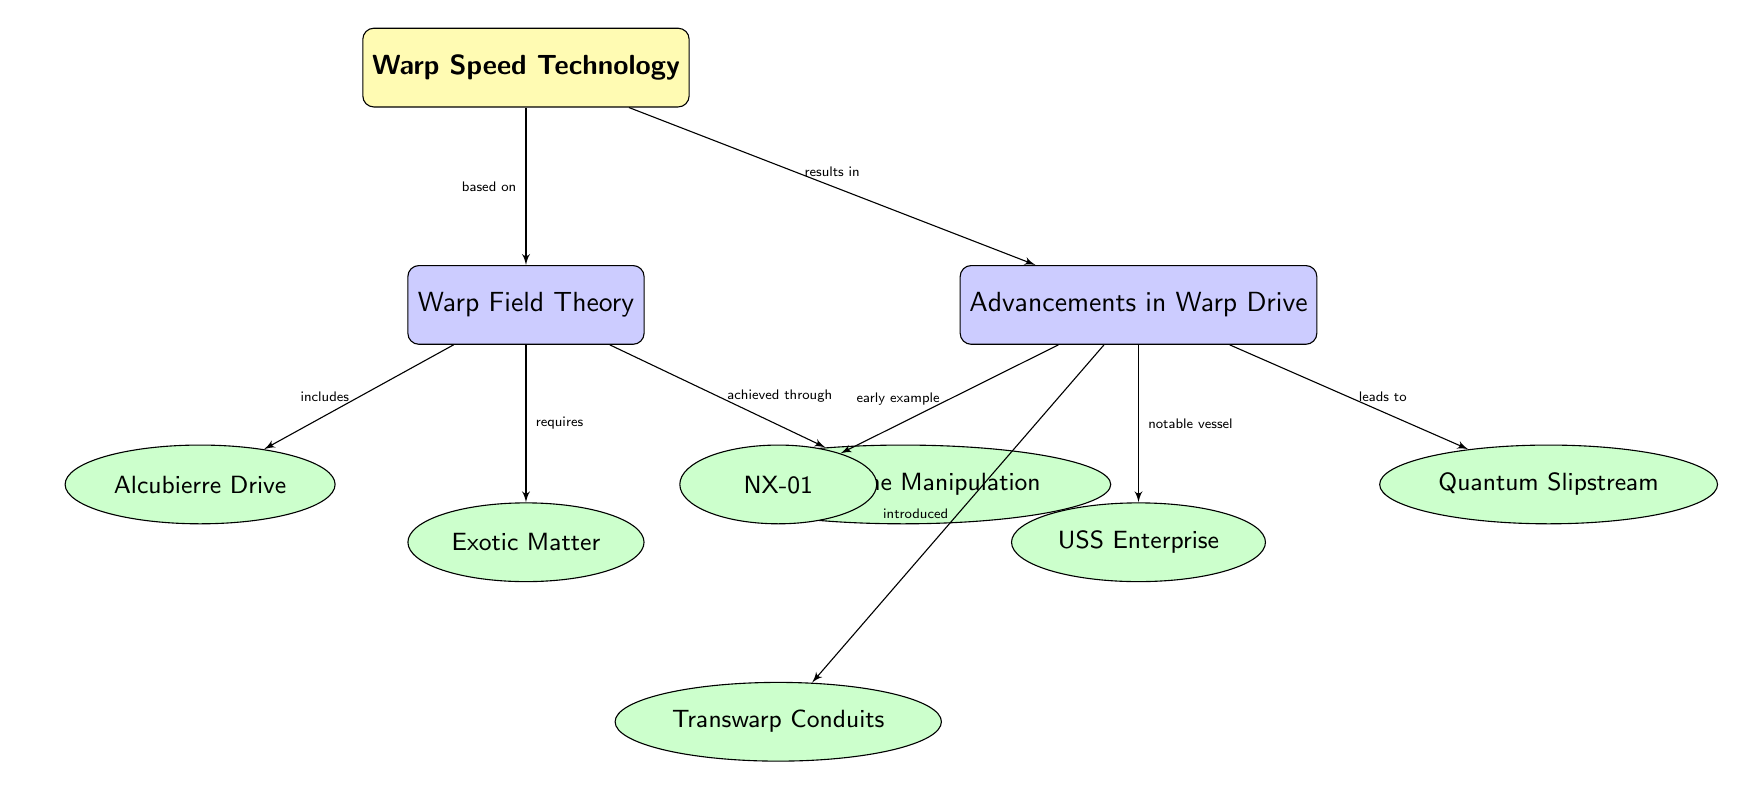What is the title of the diagram? The title is explicitly labeled at the top of the diagram, which is visually distinct and in a yellow filled box.
Answer: Warp Speed Technology How many subcategories are listed under Warp Field Theory? By counting the nodes directly beneath "Warp Field Theory," we see there are three listed: Alcubierre Drive, Exotic Matter, and Space-Time Manipulation.
Answer: 3 What does the Alcubierre Drive relate to in the context of Warp Field Theory? The line from "Warp Field Theory" to "Alcubierre Drive" is labeled as "includes," showing that the Alcubierre Drive is a part of the theory.
Answer: includes What notable vessel is mentioned in relation to advancements in Warp Drive? The node connected to "Advancements in Warp Drive" labeled "USS Enterprise" indicates this is the notable vessel referred to.
Answer: USS Enterprise Which drive introduces Transwarp Conduits? The node "Transwarp Conduits" is directly linked to the node "NX-01" under "Advancements in Warp Drive," indicating that NX-01 is the drive that introduced Transwarp Conduits.
Answer: NX-01 What is required for Warp Field Theory according to the diagram? The node below "Warp Field Theory" and connected with an arrow labeled "requires" identifies "Exotic Matter" as a requirement.
Answer: Exotic Matter What type of technology is Quantum Slipstream classified under? The arrow labeled "leads to" connects "Advancements in Warp Drive" to "Quantum Slipstream," indicating that Quantum Slipstream is an advancement or type of technology coming from warp advancements.
Answer: Quantum Slipstream How many arrows point out from the "Warp Field Theory"? By closely inspecting the diagram, we can see that there are three arrows pointing out from "Warp Field Theory" leading to the three subcategories.
Answer: 3 What category does the node "Space-Time Manipulation" belong to? The node "Space-Time Manipulation" is positioned below "Warp Field Theory," thus it is part of this overarching category.
Answer: Warp Field Theory 